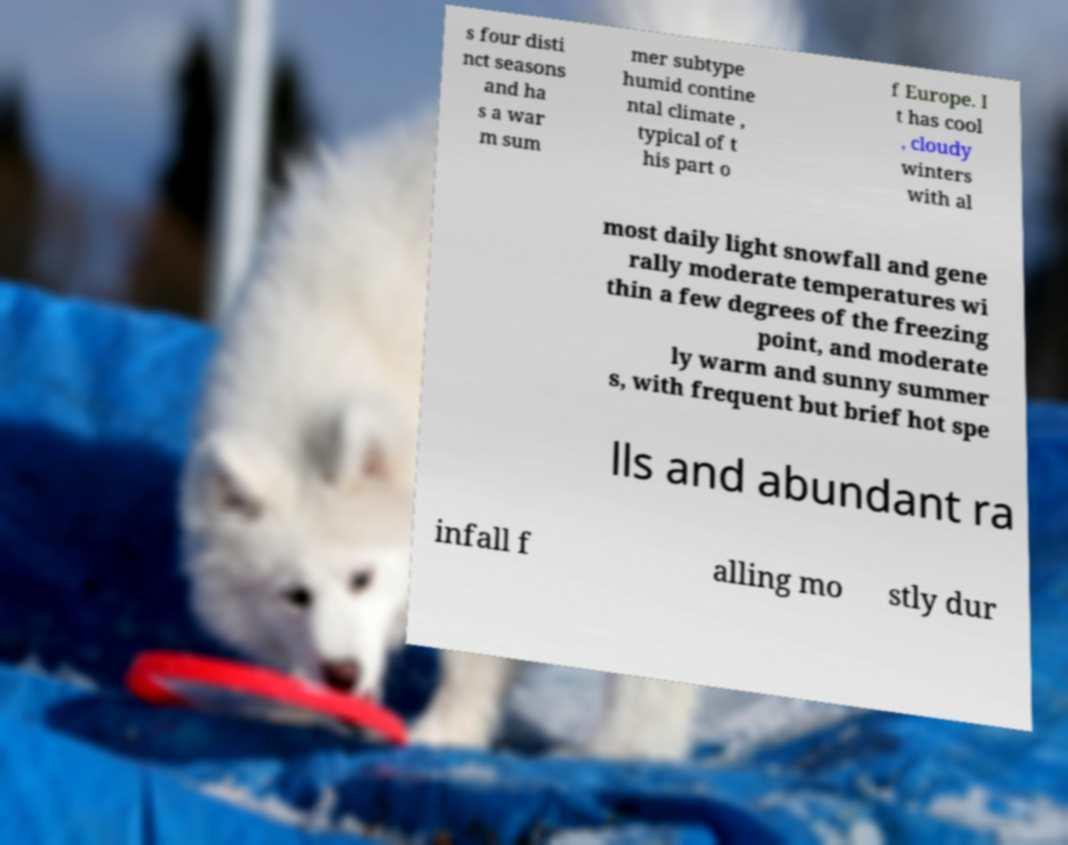Could you assist in decoding the text presented in this image and type it out clearly? s four disti nct seasons and ha s a war m sum mer subtype humid contine ntal climate , typical of t his part o f Europe. I t has cool , cloudy winters with al most daily light snowfall and gene rally moderate temperatures wi thin a few degrees of the freezing point, and moderate ly warm and sunny summer s, with frequent but brief hot spe lls and abundant ra infall f alling mo stly dur 